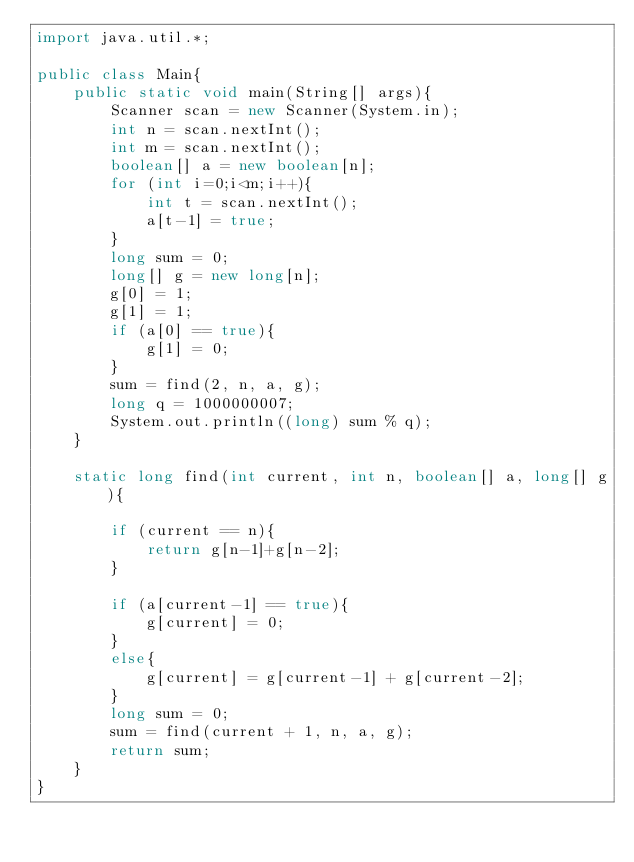<code> <loc_0><loc_0><loc_500><loc_500><_Java_>import java.util.*;

public class Main{
    public static void main(String[] args){
        Scanner scan = new Scanner(System.in);
        int n = scan.nextInt();
        int m = scan.nextInt();
        boolean[] a = new boolean[n];
        for (int i=0;i<m;i++){
            int t = scan.nextInt();
            a[t-1] = true;
        }
        long sum = 0;
        long[] g = new long[n];
        g[0] = 1;
        g[1] = 1;
        if (a[0] == true){
            g[1] = 0;
        }
        sum = find(2, n, a, g);
        long q = 1000000007;
        System.out.println((long) sum % q);
    }

    static long find(int current, int n, boolean[] a, long[] g){
        
        if (current == n){
            return g[n-1]+g[n-2];
        }
        
        if (a[current-1] == true){
            g[current] = 0;
        }
        else{
            g[current] = g[current-1] + g[current-2];
        }     
        long sum = 0;
        sum = find(current + 1, n, a, g);
        return sum;
    }
}</code> 